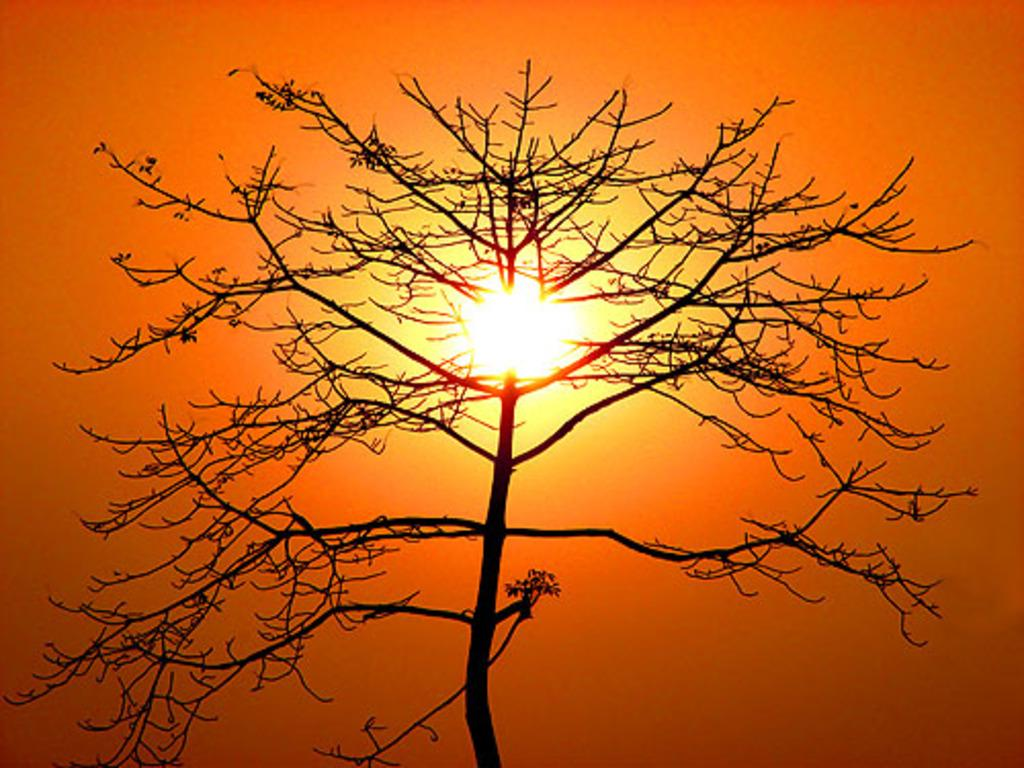What is present in the picture? There is a tree in the picture. What can be seen in the sky in the picture? There is sunlight visible in the picture. Where is the can located in the picture? There is no can present in the picture; it only features a tree and sunlight. How many people are in the crowd in the picture? There is no crowd present in the picture; it only features a tree and sunlight. 